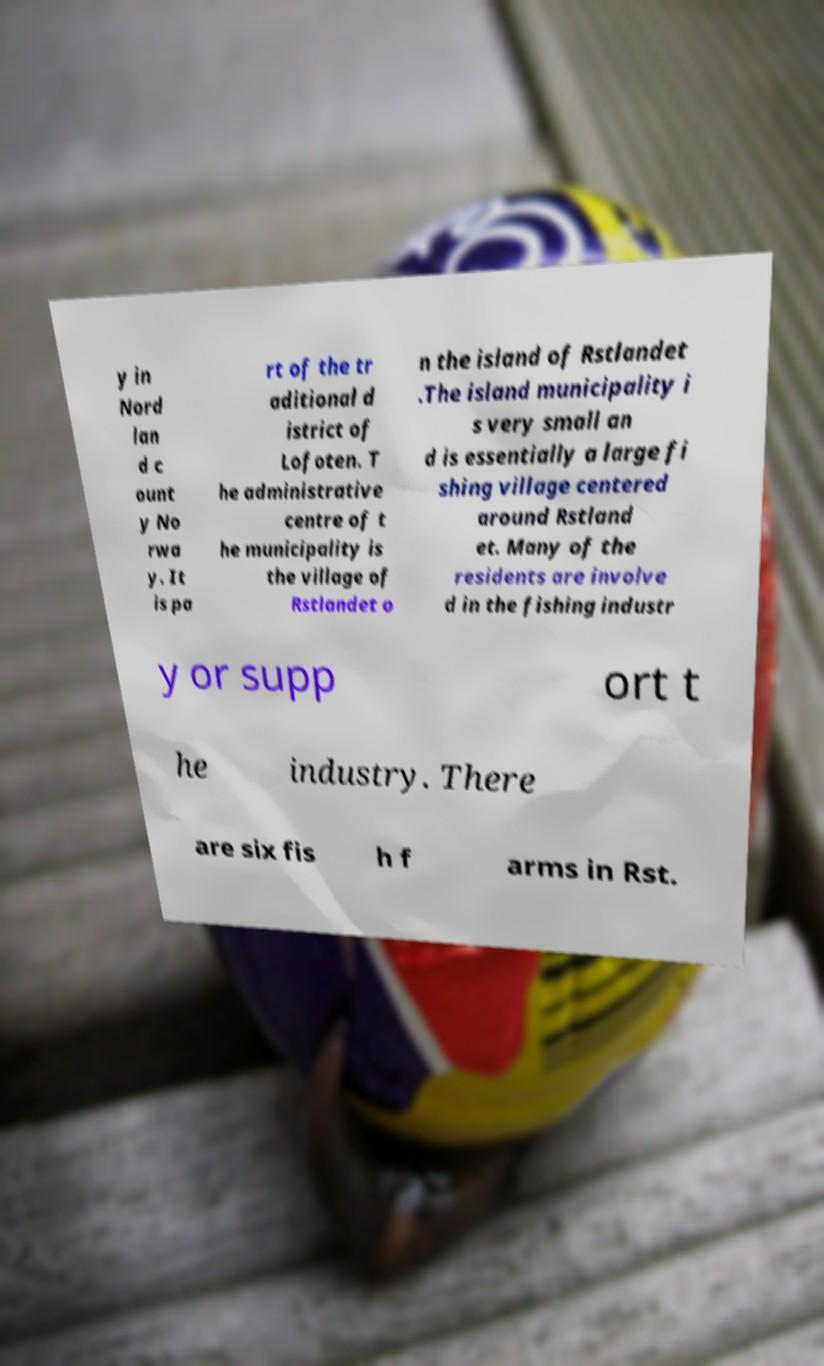Can you read and provide the text displayed in the image?This photo seems to have some interesting text. Can you extract and type it out for me? y in Nord lan d c ount y No rwa y. It is pa rt of the tr aditional d istrict of Lofoten. T he administrative centre of t he municipality is the village of Rstlandet o n the island of Rstlandet .The island municipality i s very small an d is essentially a large fi shing village centered around Rstland et. Many of the residents are involve d in the fishing industr y or supp ort t he industry. There are six fis h f arms in Rst. 